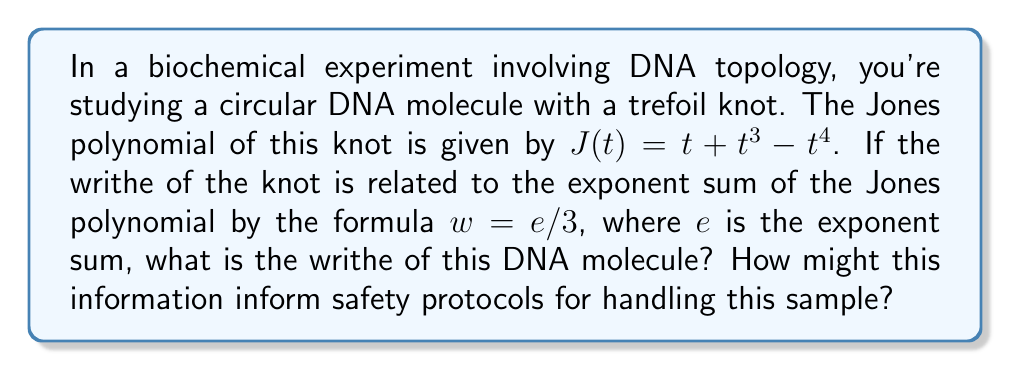Give your solution to this math problem. 1) First, we need to calculate the exponent sum of the Jones polynomial:
   $J(t) = t + t^3 - t^4$
   Exponents: 1, 3, and -4
   $e = 1 + 3 + (-4) = 0$

2) Now we can use the formula relating writhe to the exponent sum:
   $w = e/3$
   $w = 0/3 = 0$

3) The writhe of the DNA molecule is 0.

4) Interpretation for safety protocols:
   - A writhe of 0 indicates that the DNA molecule has no net over- or under-crossing preference.
   - This suggests that the molecule is in a relatively relaxed state, despite being knotted.
   - In terms of safety, this information implies:
     a) The DNA is less likely to be under tension, reducing the risk of sudden conformational changes during handling.
     b) The molecule may be more stable and less prone to breakage, which could be important when designing extraction or purification procedures.
     c) However, the presence of a trefoil knot (as indicated by the non-trivial Jones polynomial) means care must still be taken to prevent further entanglement or damage to the DNA structure.

5) Safety recommendations based on this analysis:
   - Use gentle handling techniques to maintain the current topological state.
   - Avoid procedures that might introduce additional stress or torsion to the DNA.
   - Consider using topoisomerase enzymes if the knot needs to be resolved for further analysis.
   - Implement protocols that minimize the risk of creating additional knots or links in the DNA sample.
Answer: Writhe = 0; Implies relaxed DNA state, guides gentle handling protocols 